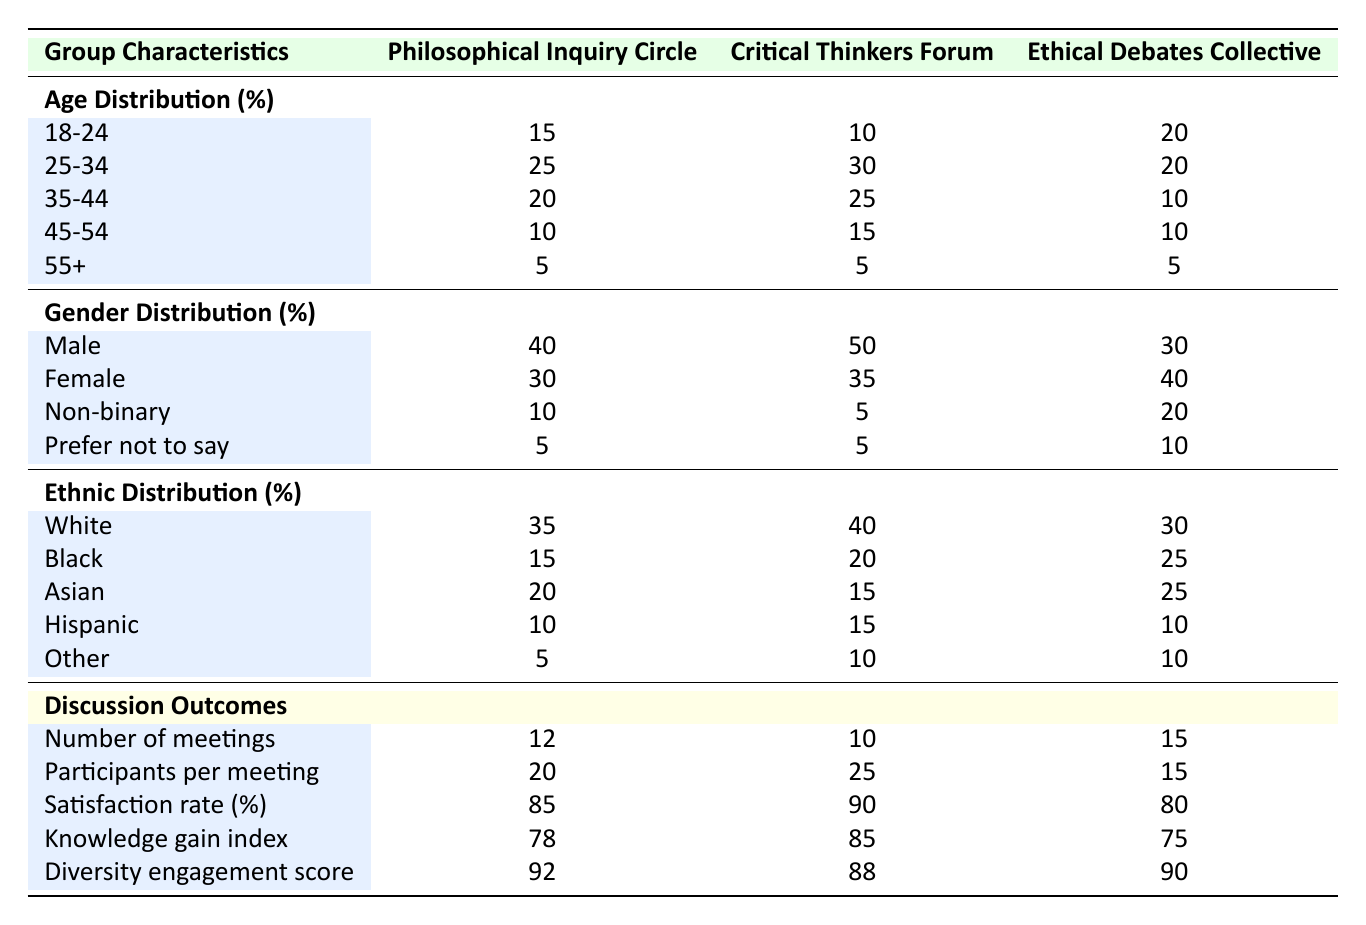What is the satisfaction rate for the Critical Thinkers Forum? The satisfaction rate for the Critical Thinkers Forum can be found in the discussion outcomes section of the table, which directly lists this value as 90%.
Answer: 90% Which group has the highest percentage of female participants? By comparing the gender distribution percentages, the Ethical Debates Collective has 40% female participants, which is higher than the other groups (Philosophical Inquiry Circle at 30% and Critical Thinkers Forum at 35%).
Answer: Ethical Debates Collective What is the average number of participants per meeting across the three discussion groups? To calculate the average, sum the participants per meeting across all groups: (20 + 25 + 15) = 60, then divide by the number of groups, which is 3: 60 / 3 = 20.
Answer: 20 Is there a higher diversity engagement score for the Philosophical Inquiry Circle than for the Ethical Debates Collective? Comparing the diversity engagement scores, the Philosophical Inquiry Circle has 92 while the Ethical Debates Collective has 90. Since 92 is greater than 90, the statement is true.
Answer: Yes Which age group has the lowest representation in the Ethical Debates Collective? In the age distribution for the Ethical Debates Collective, the lowest percentage is 10% for both the 35-44 and 45-54 age groups.
Answer: 35-44 and 45-54 (both have 10%) What is the total percentage of participants aged 18-24 and 55+ in the Philosophical Inquiry Circle? To find this total, add the percentages of participants aged 18-24 (15%) and 55+ (5%): 15 + 5 = 20%.
Answer: 20% Which group has the lowest knowledge gain index? The knowledge gain index values show that the Ethical Debates Collective has the lowest score at 75 compared to the others (78 and 85).
Answer: Ethical Debates Collective Is there a direct correlation between the number of meetings and the diversity engagement score for the Critical Thinkers Forum? The Critical Thinkers Forum had 10 meetings and a diversity engagement score of 88. The relationship could be analyzed by comparing to other groups, but without more data on consistent scoring across different meeting counts, a simple correlation cannot be established.
Answer: Not determinable from the table What is the sum of the percentages of non-binary participants across all discussion groups? The non-binary percentages in each group are: 10% for the Philosophical Inquiry Circle, 5% for the Critical Thinkers Forum, and 20% for the Ethical Debates Collective. Adding these gives: 10 + 5 + 20 = 35%.
Answer: 35% 